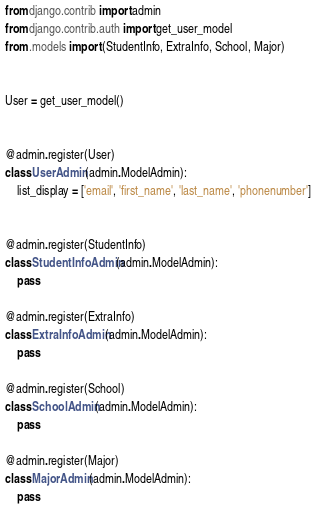Convert code to text. <code><loc_0><loc_0><loc_500><loc_500><_Python_>from django.contrib import admin
from django.contrib.auth import get_user_model
from .models import (StudentInfo, ExtraInfo, School, Major)


User = get_user_model()


@admin.register(User)
class UserAdmin(admin.ModelAdmin):
    list_display = ['email', 'first_name', 'last_name', 'phonenumber']


@admin.register(StudentInfo)
class StudentInfoAdmin(admin.ModelAdmin):
    pass

@admin.register(ExtraInfo)
class ExtraInfoAdmin(admin.ModelAdmin):
    pass

@admin.register(School)
class SchoolAdmin(admin.ModelAdmin):
    pass

@admin.register(Major)
class MajorAdmin(admin.ModelAdmin):
    pass</code> 